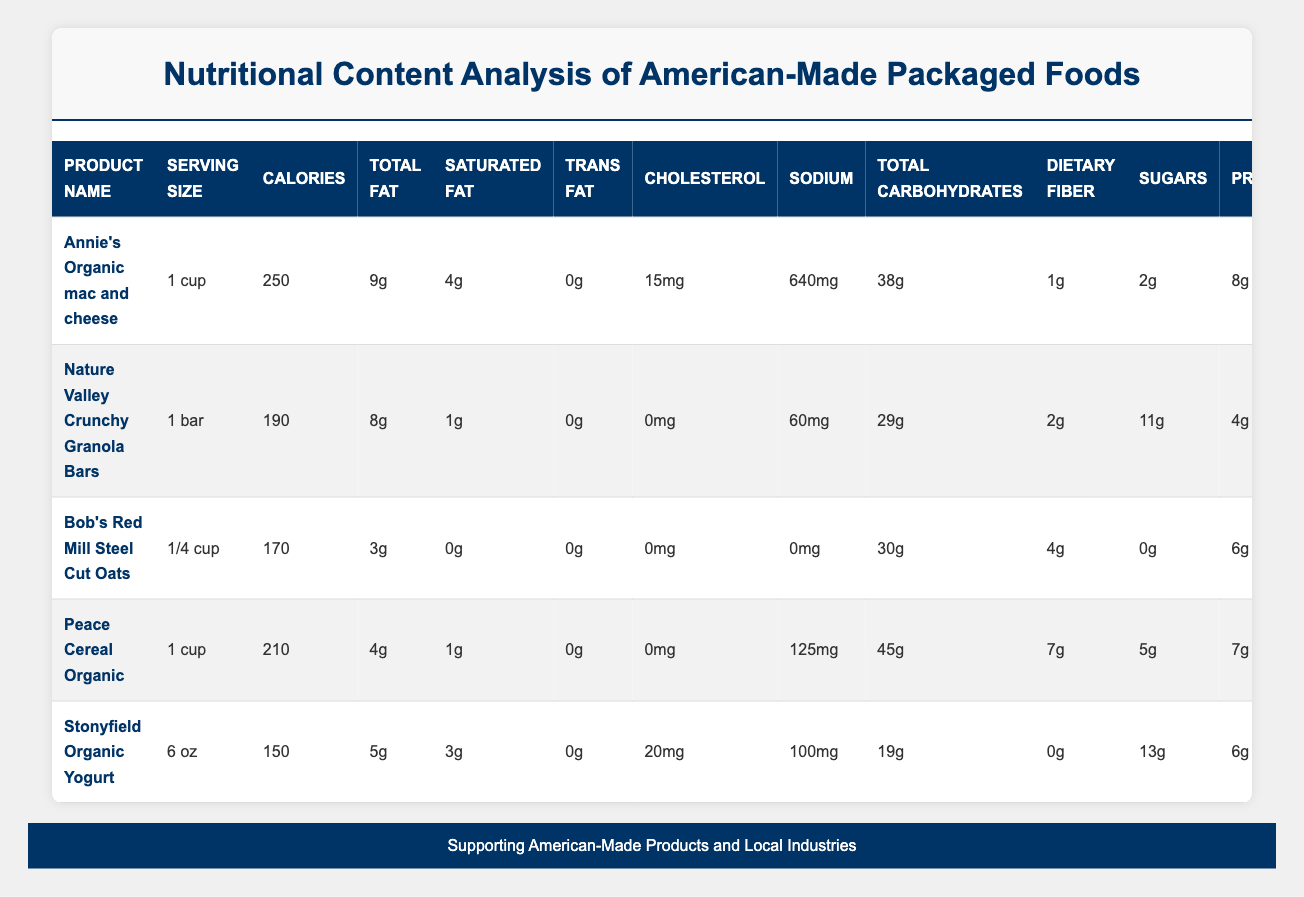What is the total amount of protein in Annie's Organic mac and cheese? The table shows that Annie's Organic mac and cheese contains 8g of protein per serving. Thus, the total amount of protein in this product is 8g.
Answer: 8g Which product has the highest calorie count? Among the products listed, Annie's Organic mac and cheese has the highest calorie count at 250 calories per serving.
Answer: 250 calories Is there any product that contains trans fat? All products listed in the table show a trans fat content of 0g. Therefore, none of the products contain trans fat.
Answer: No What is the average amount of dietary fiber across all the products? The amount of dietary fiber in each product is 1g (Annie's), 2g (Nature Valley), 4g (Bob's Red Mill), 7g (Peace Cereal), and 0g (Stonyfield). Adding these gives 1 + 2 + 4 + 7 + 0 = 14g. Dividing by the number of products (5) gives an average of 14g / 5 = 2.8g of dietary fiber.
Answer: 2.8g How much sodium is in Stonyfield Organic Yogurt compared to Nature Valley Crunchy Granola Bars? Stonyfield Organic Yogurt contains 100mg of sodium while Nature Valley Crunchy Granola Bars have 60mg. The comparison shows that Stonyfield has 40mg more sodium than Nature Valley.
Answer: 40mg more What percentage of the daily value of calcium does Stonyfield Organic Yogurt provide? Stonyfield Organic Yogurt provides 15% of the Daily Value (DV) of calcium per serving. Thus, Stonyfield contributes 15% of the recommended daily intake of calcium.
Answer: 15% Which product contains the most sugar? Analyzing the sugar content: Annie's has 2g, Nature Valley has 11g, Bob's Red Mill has 0g, Peace Cereal has 5g, and Stonyfield has 13g. The highest sugar content is in Stonyfield Organic Yogurt with 13g.
Answer: 13g What is the difference in potassium content between Peace Cereal and Bob's Red Mill Steel Cut Oats? Peace Cereal contains 180mg of potassium while Bob's Red Mill contains 154mg. The difference in potassium content is calculated as 180mg - 154mg = 26mg, indicating that Peace Cereal has 26mg more potassium.
Answer: 26mg 